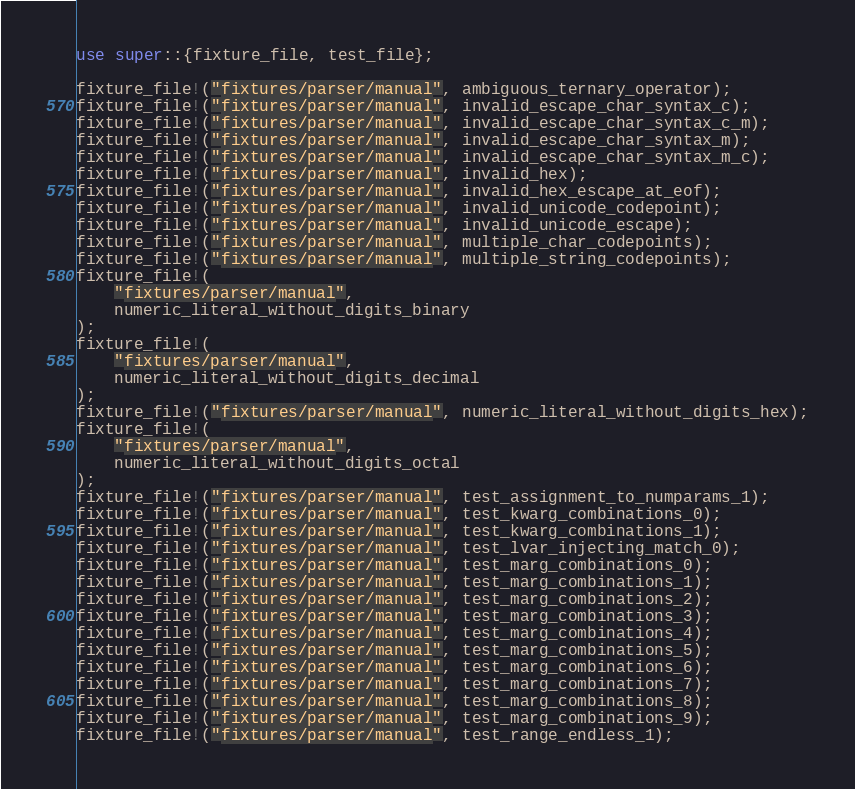Convert code to text. <code><loc_0><loc_0><loc_500><loc_500><_Rust_>use super::{fixture_file, test_file};

fixture_file!("fixtures/parser/manual", ambiguous_ternary_operator);
fixture_file!("fixtures/parser/manual", invalid_escape_char_syntax_c);
fixture_file!("fixtures/parser/manual", invalid_escape_char_syntax_c_m);
fixture_file!("fixtures/parser/manual", invalid_escape_char_syntax_m);
fixture_file!("fixtures/parser/manual", invalid_escape_char_syntax_m_c);
fixture_file!("fixtures/parser/manual", invalid_hex);
fixture_file!("fixtures/parser/manual", invalid_hex_escape_at_eof);
fixture_file!("fixtures/parser/manual", invalid_unicode_codepoint);
fixture_file!("fixtures/parser/manual", invalid_unicode_escape);
fixture_file!("fixtures/parser/manual", multiple_char_codepoints);
fixture_file!("fixtures/parser/manual", multiple_string_codepoints);
fixture_file!(
    "fixtures/parser/manual",
    numeric_literal_without_digits_binary
);
fixture_file!(
    "fixtures/parser/manual",
    numeric_literal_without_digits_decimal
);
fixture_file!("fixtures/parser/manual", numeric_literal_without_digits_hex);
fixture_file!(
    "fixtures/parser/manual",
    numeric_literal_without_digits_octal
);
fixture_file!("fixtures/parser/manual", test_assignment_to_numparams_1);
fixture_file!("fixtures/parser/manual", test_kwarg_combinations_0);
fixture_file!("fixtures/parser/manual", test_kwarg_combinations_1);
fixture_file!("fixtures/parser/manual", test_lvar_injecting_match_0);
fixture_file!("fixtures/parser/manual", test_marg_combinations_0);
fixture_file!("fixtures/parser/manual", test_marg_combinations_1);
fixture_file!("fixtures/parser/manual", test_marg_combinations_2);
fixture_file!("fixtures/parser/manual", test_marg_combinations_3);
fixture_file!("fixtures/parser/manual", test_marg_combinations_4);
fixture_file!("fixtures/parser/manual", test_marg_combinations_5);
fixture_file!("fixtures/parser/manual", test_marg_combinations_6);
fixture_file!("fixtures/parser/manual", test_marg_combinations_7);
fixture_file!("fixtures/parser/manual", test_marg_combinations_8);
fixture_file!("fixtures/parser/manual", test_marg_combinations_9);
fixture_file!("fixtures/parser/manual", test_range_endless_1);</code> 